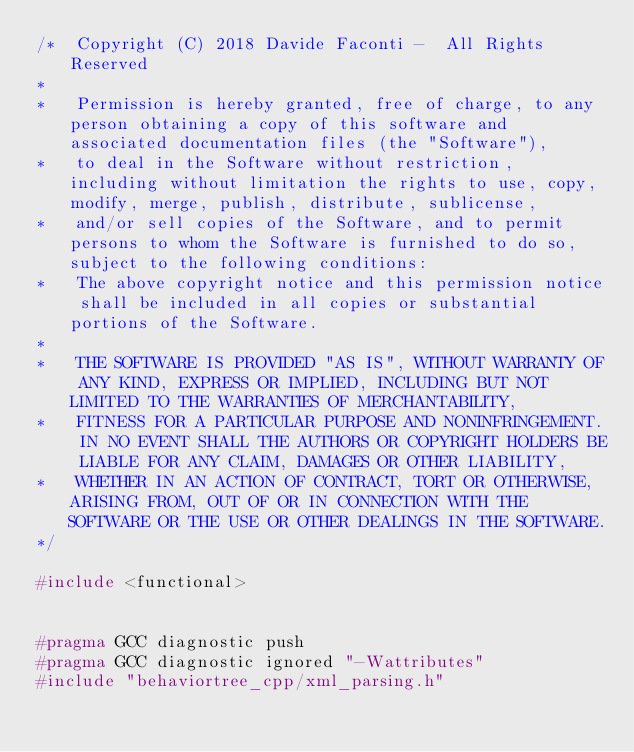Convert code to text. <code><loc_0><loc_0><loc_500><loc_500><_C++_>/*  Copyright (C) 2018 Davide Faconti -  All Rights Reserved
*
*   Permission is hereby granted, free of charge, to any person obtaining a copy of this software and associated documentation files (the "Software"),
*   to deal in the Software without restriction, including without limitation the rights to use, copy, modify, merge, publish, distribute, sublicense,
*   and/or sell copies of the Software, and to permit persons to whom the Software is furnished to do so, subject to the following conditions:
*   The above copyright notice and this permission notice shall be included in all copies or substantial portions of the Software.
*
*   THE SOFTWARE IS PROVIDED "AS IS", WITHOUT WARRANTY OF ANY KIND, EXPRESS OR IMPLIED, INCLUDING BUT NOT LIMITED TO THE WARRANTIES OF MERCHANTABILITY,
*   FITNESS FOR A PARTICULAR PURPOSE AND NONINFRINGEMENT. IN NO EVENT SHALL THE AUTHORS OR COPYRIGHT HOLDERS BE LIABLE FOR ANY CLAIM, DAMAGES OR OTHER LIABILITY,
*   WHETHER IN AN ACTION OF CONTRACT, TORT OR OTHERWISE, ARISING FROM, OUT OF OR IN CONNECTION WITH THE SOFTWARE OR THE USE OR OTHER DEALINGS IN THE SOFTWARE.
*/

#include <functional>


#pragma GCC diagnostic push
#pragma GCC diagnostic ignored "-Wattributes"
#include "behaviortree_cpp/xml_parsing.h"</code> 